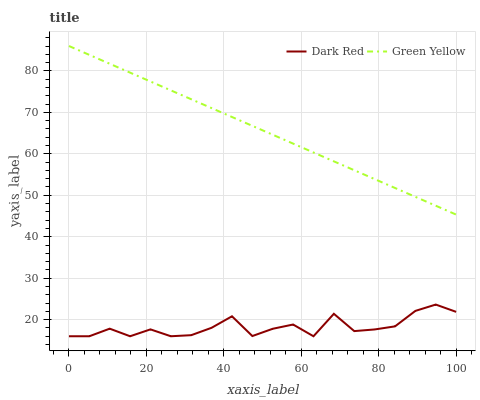Does Dark Red have the minimum area under the curve?
Answer yes or no. Yes. Does Green Yellow have the maximum area under the curve?
Answer yes or no. Yes. Does Green Yellow have the minimum area under the curve?
Answer yes or no. No. Is Green Yellow the smoothest?
Answer yes or no. Yes. Is Dark Red the roughest?
Answer yes or no. Yes. Is Green Yellow the roughest?
Answer yes or no. No. Does Green Yellow have the lowest value?
Answer yes or no. No. Does Green Yellow have the highest value?
Answer yes or no. Yes. Is Dark Red less than Green Yellow?
Answer yes or no. Yes. Is Green Yellow greater than Dark Red?
Answer yes or no. Yes. Does Dark Red intersect Green Yellow?
Answer yes or no. No. 